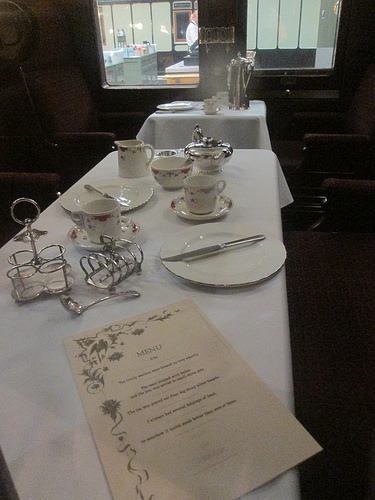<image>
Is there a cup on the plate? No. The cup is not positioned on the plate. They may be near each other, but the cup is not supported by or resting on top of the plate. 